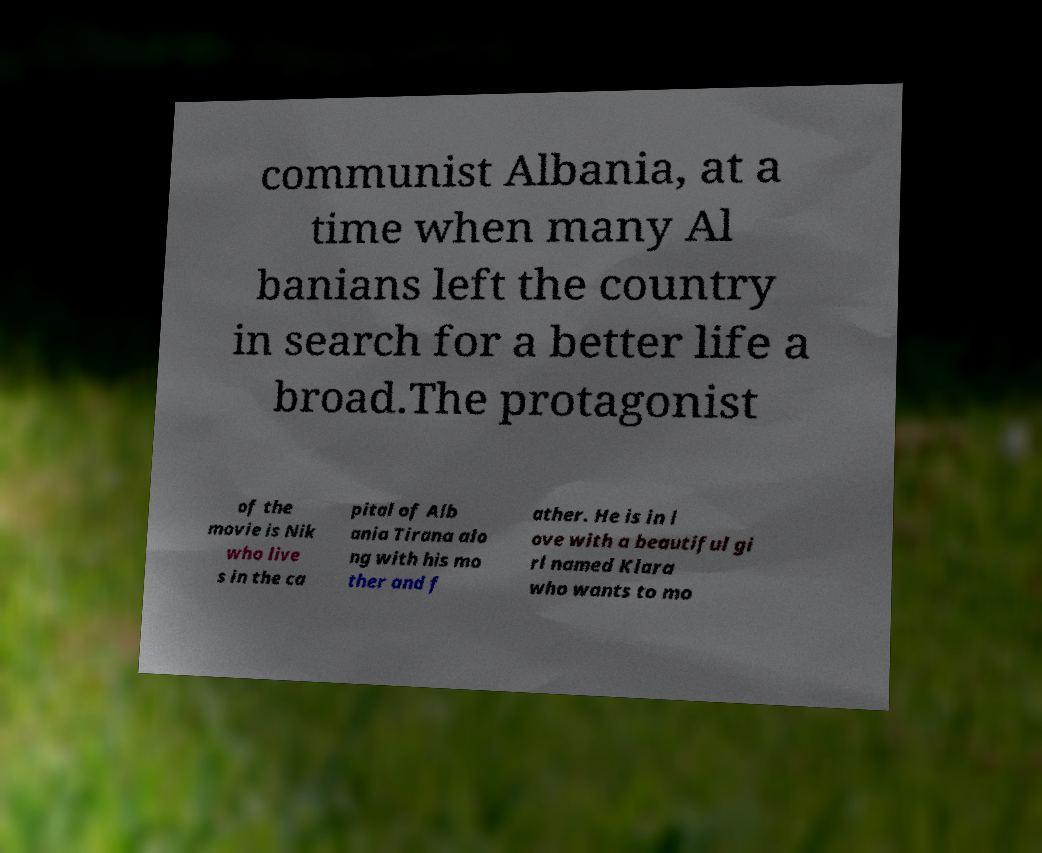Could you assist in decoding the text presented in this image and type it out clearly? communist Albania, at a time when many Al banians left the country in search for a better life a broad.The protagonist of the movie is Nik who live s in the ca pital of Alb ania Tirana alo ng with his mo ther and f ather. He is in l ove with a beautiful gi rl named Klara who wants to mo 